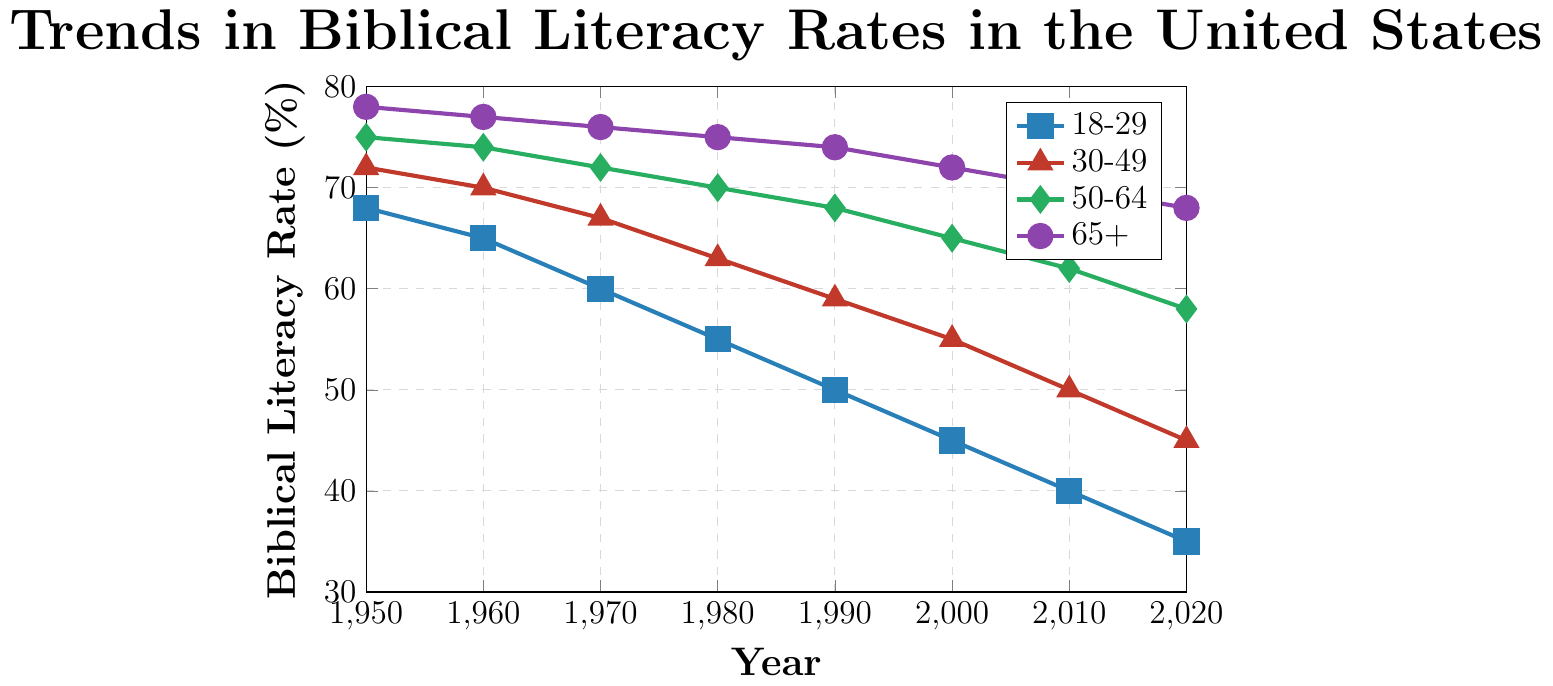What is the trend in biblical literacy rates for the 18-29 age group from 1950 to 2020? The biblical literacy rate for the 18-29 age group consistently decreases from 68% in 1950 to 35% in 2020, as seen by the downward sloping line marked with squares.
Answer: Decreasing Which age group has the highest biblical literacy rate in 2020? In the year 2020, the age group 65+ has the highest biblical literacy rate at 68%, as indicated by the purple line with circle markers.
Answer: 65+ What was the biblical literacy rate difference between the 30-49 and 50-64 age groups in 2000? In 2000, the biblical literacy rate for the 30-49 age group is 55% and for the 50-64 age group is 65%. The difference is calculated as 65% - 55% = 10%.
Answer: 10% How does the trend in biblical literacy rates for the age group 65+ compare to the trend for the age group 18-29? Both age groups show a decreasing trend in biblical literacy rates from 1950 to 2020. However, the rate of decrease is faster for the 18-29 age group compared to the 65+ age group, as indicated by the steeper downward slope of the 18-29 line compared to the 65+ line.
Answer: Faster for 18-29 What is the average biblical literacy rate for the 50-64 age group across all years? The average is calculated by summing the biblical literacy rates for the 50-64 age group across all years and then dividing by the total number of years: (75 + 74 + 72 + 70 + 68 + 65 + 62 + 58) / 8 = 68%.
Answer: 68% In which decade did the 18-29 age group experience the largest drop in biblical literacy rate? The 18-29 age group experienced the largest drop in biblical literacy rate from 1980 to 1990, where the rate dropped from 55% to 50%, a decrease of 5%.
Answer: 1980-1990 Compare the biblical literacy rate for the 65+ age group in 1950 to the rate for the 18-29 age group in 2020. In 1950, the biblical literacy rate for the 65+ age group is 78%. In 2020, the rate for the 18-29 age group is 35%. The 65+ rate is more than twice that of the 18-29 rate in these years.
Answer: More than twice How much did the biblical literacy rate for the 30-49 age group change from 1950 to 2020? The biblical literacy rate for the 30-49 age group decreased from 72% in 1950 to 45% in 2020. The change is calculated as 72% - 45% = 27%.
Answer: 27% What color represents the data for the age group 50-64 in the chart? The line representing the age group 50-64 is green, as indicated by the legend and the color of the line and marker (diamond shape) in the chart.
Answer: Green Which age group's biblical literacy rate remained above 60% until 2020? The 65+ age group's biblical literacy rate remained above 60% until 2020, with a literacy rate of 68% in that year as represented by the purple line with circle markers.
Answer: 65+ 